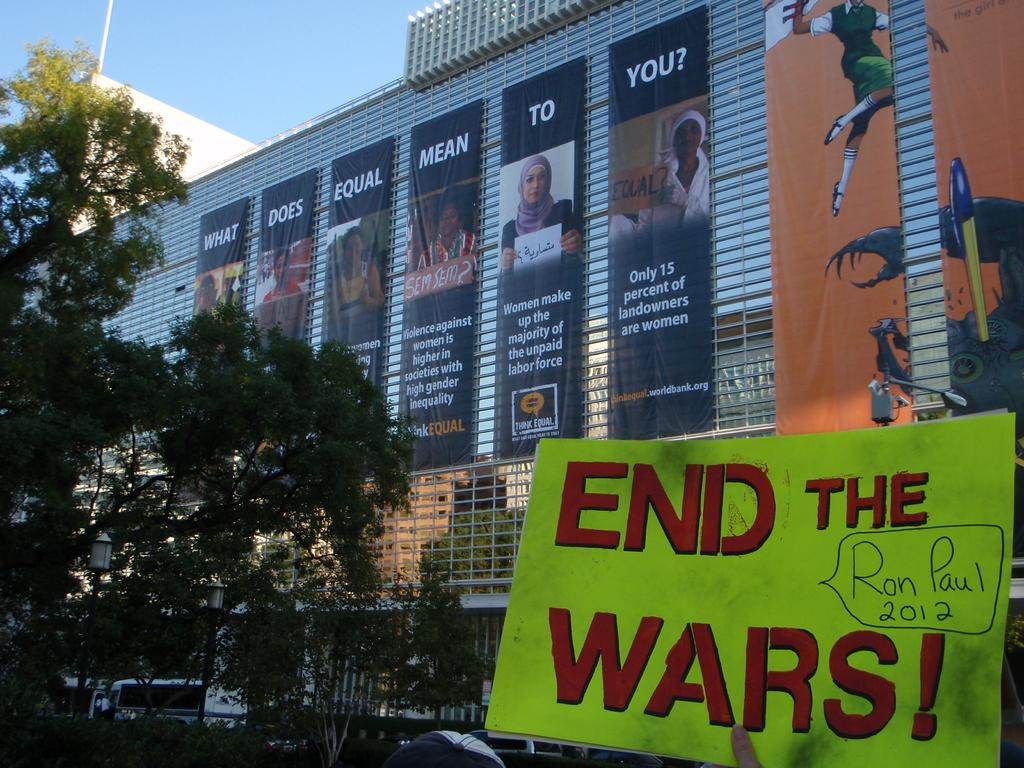What type of structure is visible in the image? There is a building in the image. What decorative elements can be seen in the image? There are banners in the image. What type of natural elements are present in the image? There are trees in the image. What mode of transportation is visible in the image? There is a vehicle in the image. What type of informational material is present in the image? There is a poster in the image. What is the color of the sky in the image? The sky is pale blue in the image. What type of written communication is present in the image? There is text visible in the image. What part of a person can be seen in the image? A finger of a person is present in the image. Can you tell me how many pans are being used to generate steam in the image? There is no steam or pan present in the image. How many cents are visible on the poster in the image? There is no mention of currency or cents on the poster in the image. 